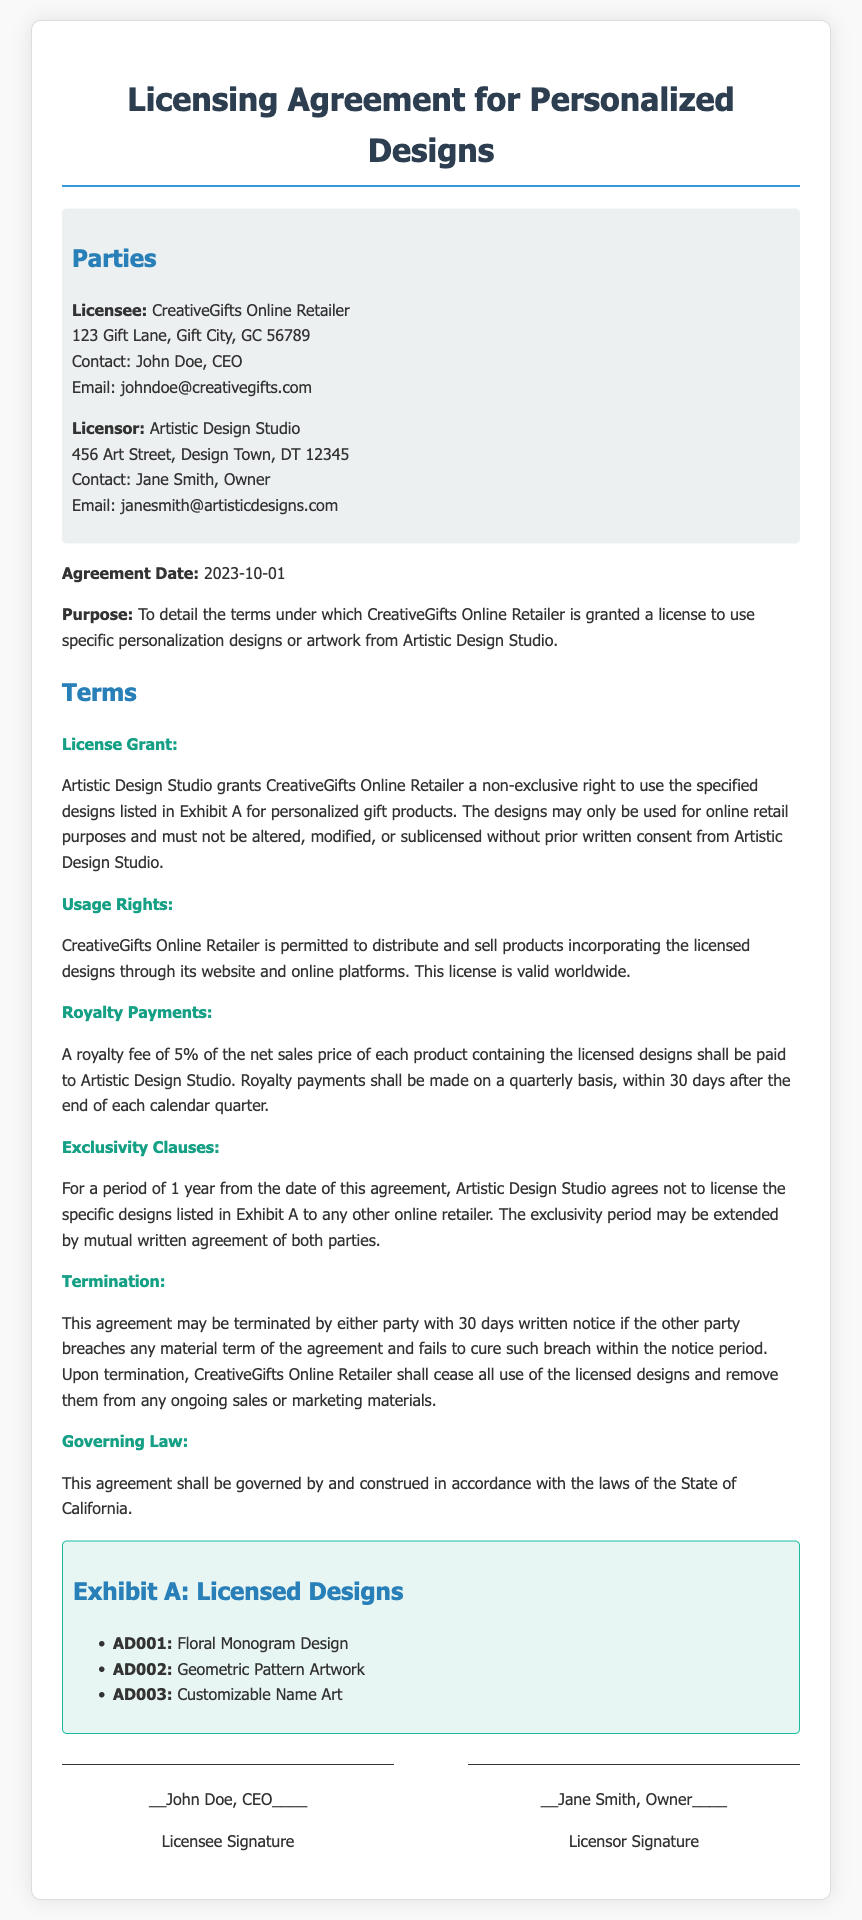What is the name of the Licensee? The Licensee is the entity that is granted a license, which is stated clearly in the contract.
Answer: CreativeGifts Online Retailer Who is the Licensor? The Licensor is the entity granting the license, which is identified in the contract.
Answer: Artistic Design Studio What is the royalty percentage? The royalty percentage is specified in the document, relating to payments based on net sales prices.
Answer: 5% What is the duration of the exclusivity period? The contract specifies a period of exclusivity for the designs, indicating how long it lasts.
Answer: 1 year How often are royalty payments made? The frequency of the royalty payments is outlined in the contract details.
Answer: Quarterly What must CreativeGifts do upon termination of the agreement? The contract outlines the obligations of CreativeGifts upon termination of the licensing agreement.
Answer: Cease all use of the licensed designs What governing law applies to this agreement? The document specifies the legal jurisdiction governing the agreement, which is crucial for enforcement.
Answer: State of California What is the date of the agreement? The date of the agreement is clearly stated in the contract, marking when it became effective.
Answer: 2023-10-01 Which design is labeled AD002? The document lists specific licensed designs and their corresponding identifiers; this identifies the design in question.
Answer: Geometric Pattern Artwork 